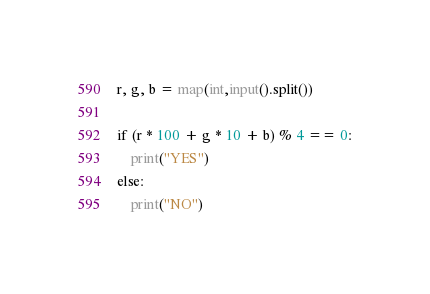Convert code to text. <code><loc_0><loc_0><loc_500><loc_500><_Python_>r, g, b = map(int,input().split())

if (r * 100 + g * 10 + b) % 4 == 0:
    print("YES")
else:
    print("NO")</code> 